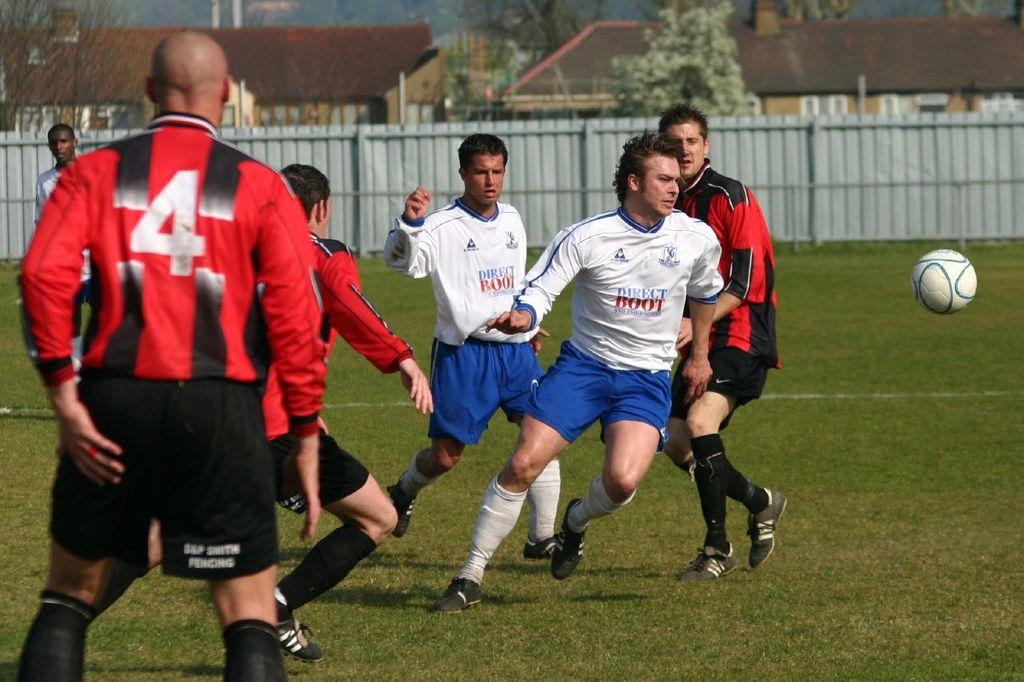<image>
Relay a brief, clear account of the picture shown. Soccer players wear uniforms with Direct Boot on the shirts. 